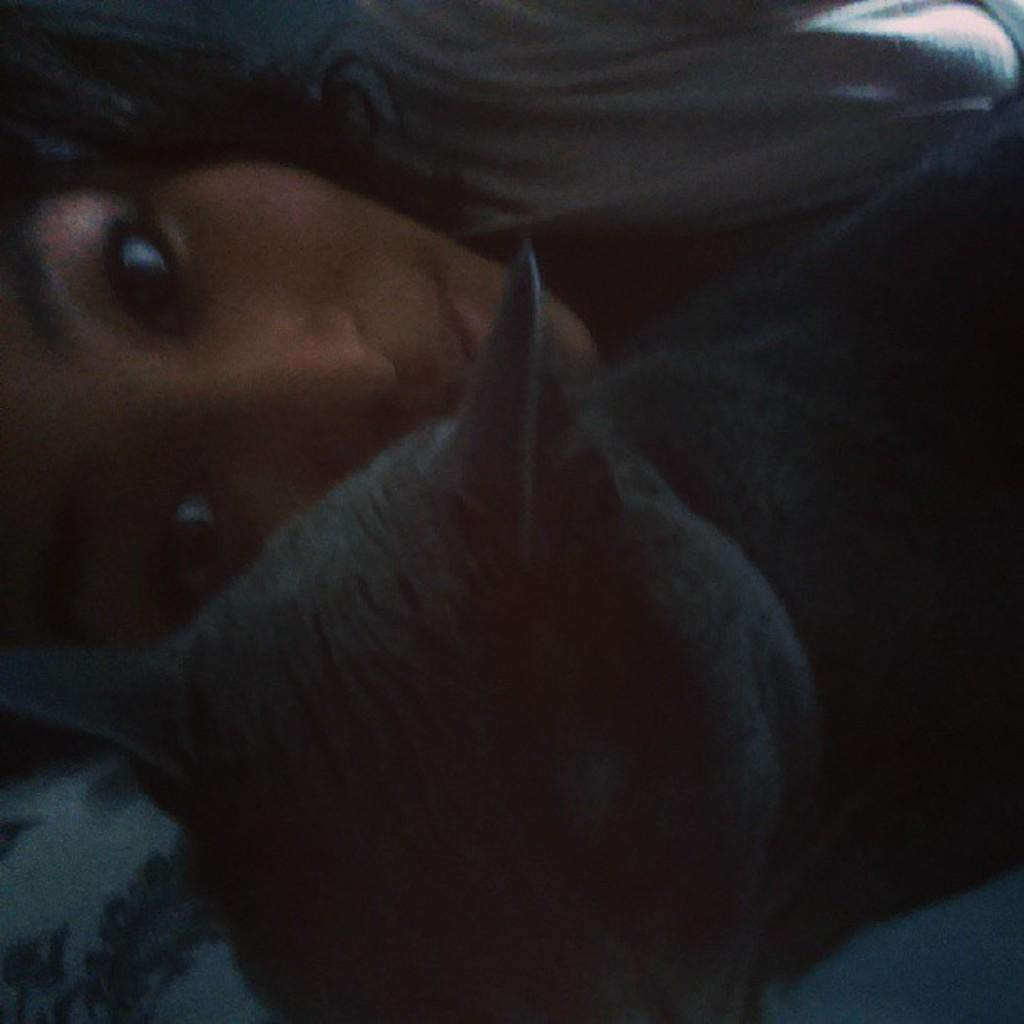Who is present in the image? There is a girl in the image. What animal is beside the girl in the image? There is a cat beside the girl in the image. How many pizzas are being delivered by the chain in the image? There are no pizzas or chains present in the image; it features a girl and a cat. What type of building is visible in the background of the image? There is no building visible in the background of the image; it only shows the girl and the cat. 